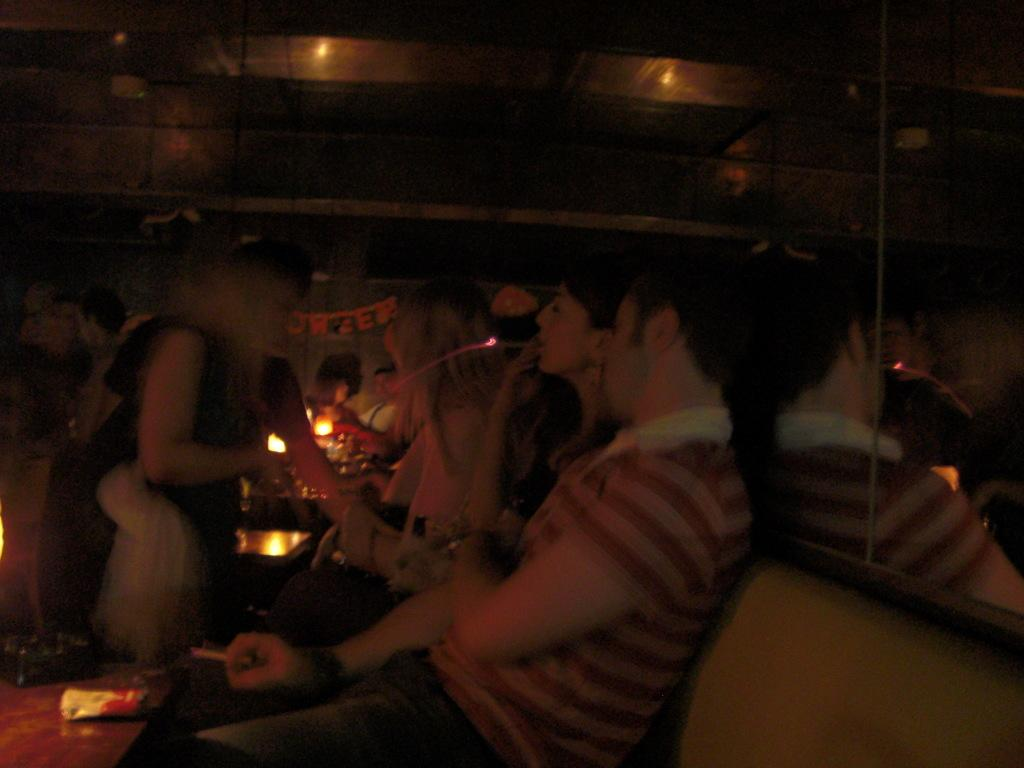What are the people in the image doing? There are people sitting on the sofa in the image. What activity are some of the people engaged in? Some people are smoking in the image. What are the people holding in the image? Some people are holding objects in the image. What can be seen in the background of the image? There are lights visible in the image. What reflective surface is present in the image? There is a mirror in the image. What is on the table in the image? There are objects on the table in the image. How many mice can be seen running around on the table in the image? There are no mice present in the image; it only features people sitting on a sofa, smoking, and holding objects. What is the relation between the people in the image? The provided facts do not give any information about the relationship between the people in the image. --- Facts: 1. There is a car in the image. 2. The car is parked on the street. 3. There are trees in the background of the image. 4. The sky is visible in the image. 5. There is a traffic light near the car. Absurd Topics: parrot, dance, ocean Conversation: What is the main subject of the image? The main subject of the image is a car. Where is the car located in the image? The car is parked on the street in the image. What can be seen in the background of the image? There are trees in the background of the image. What is visible at the top of the image? The sky is visible in the image. What traffic control device is near the car? There is a traffic light near the car in the image. Reasoning: Let's think step by step in order to produce the conversation. We start by identifying the main subject of the image, which is the car. Then, we describe the car's location and the surrounding environment, including the trees in the background and the sky visible at the top of the image. We also mention the traffic light near the car as a specific detail about the image. Absurd Question/Answer: Can you see a parrot dancing near the ocean in the image? There is no parrot or ocean present in the image; it only features a car parked on the street with a traffic light nearby. 